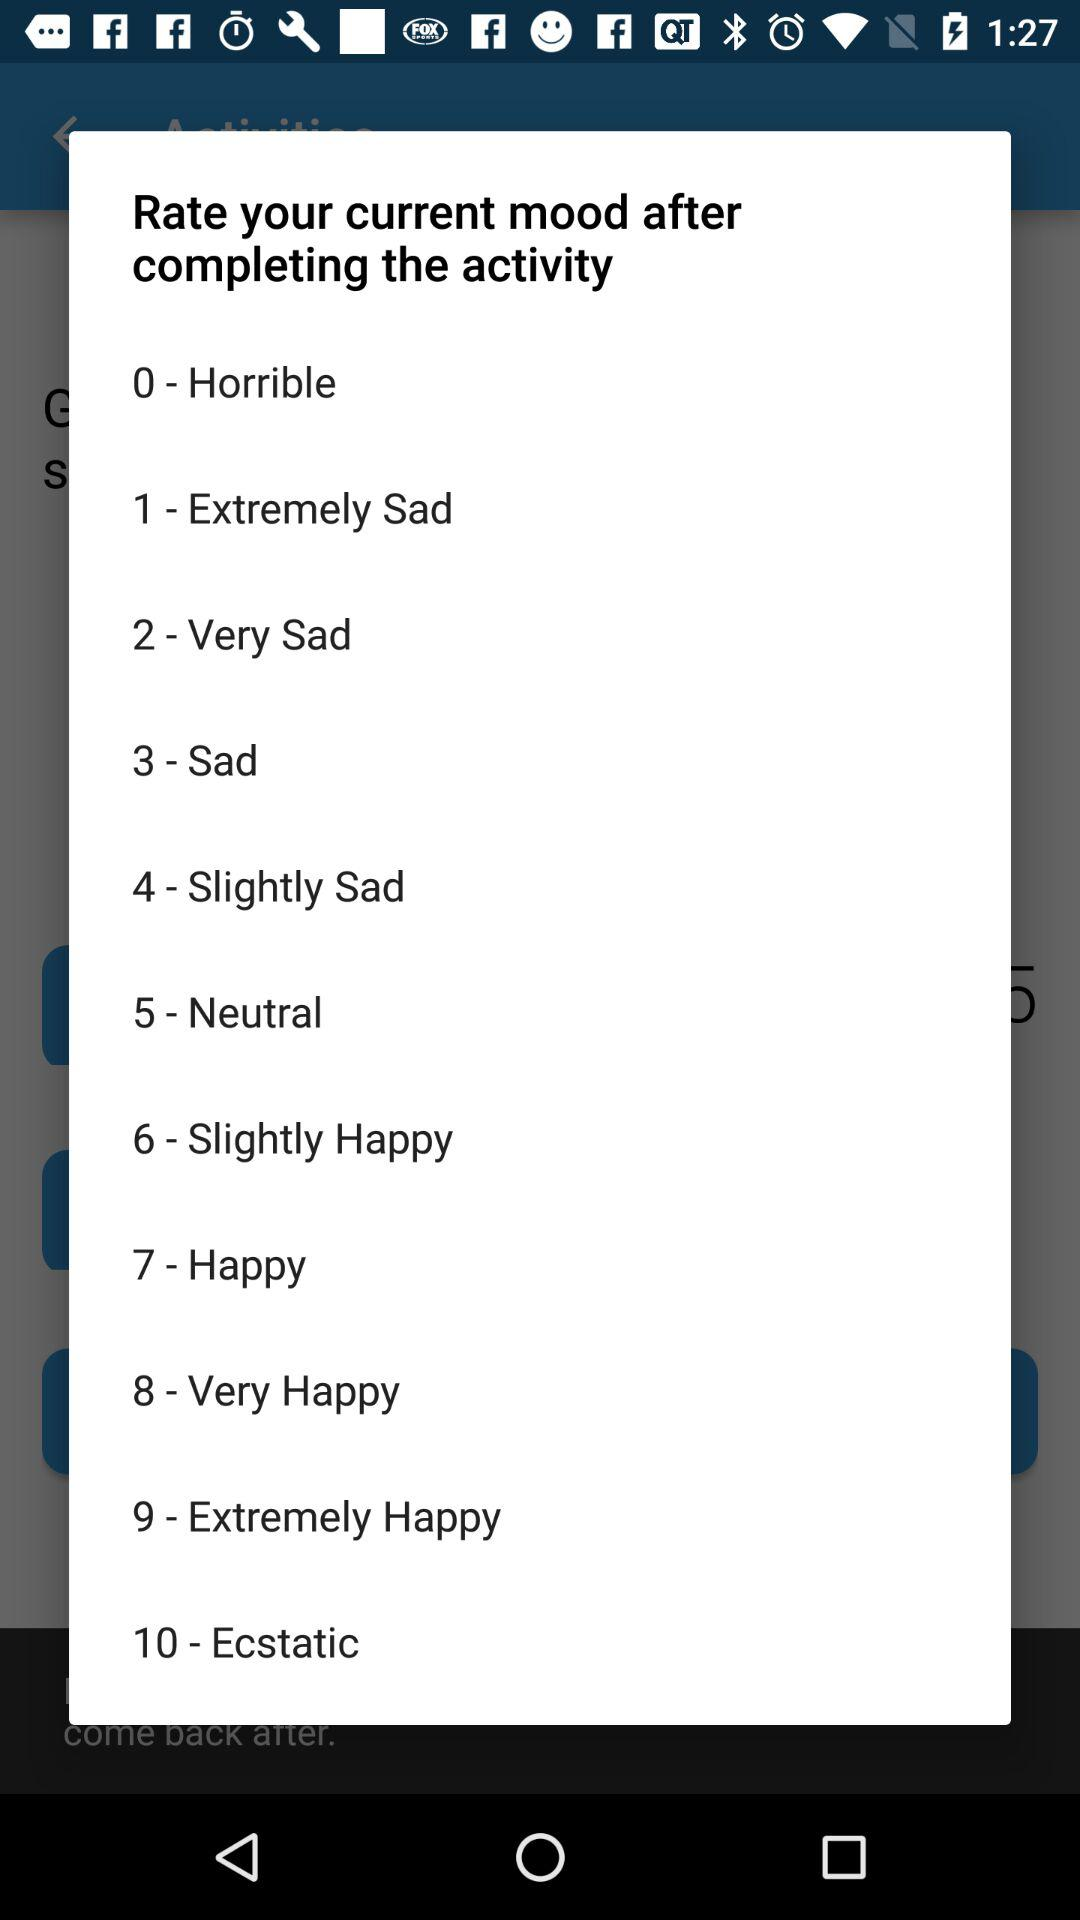What is the rating number for the happy mood? The rating number for the happy mood is 7. 